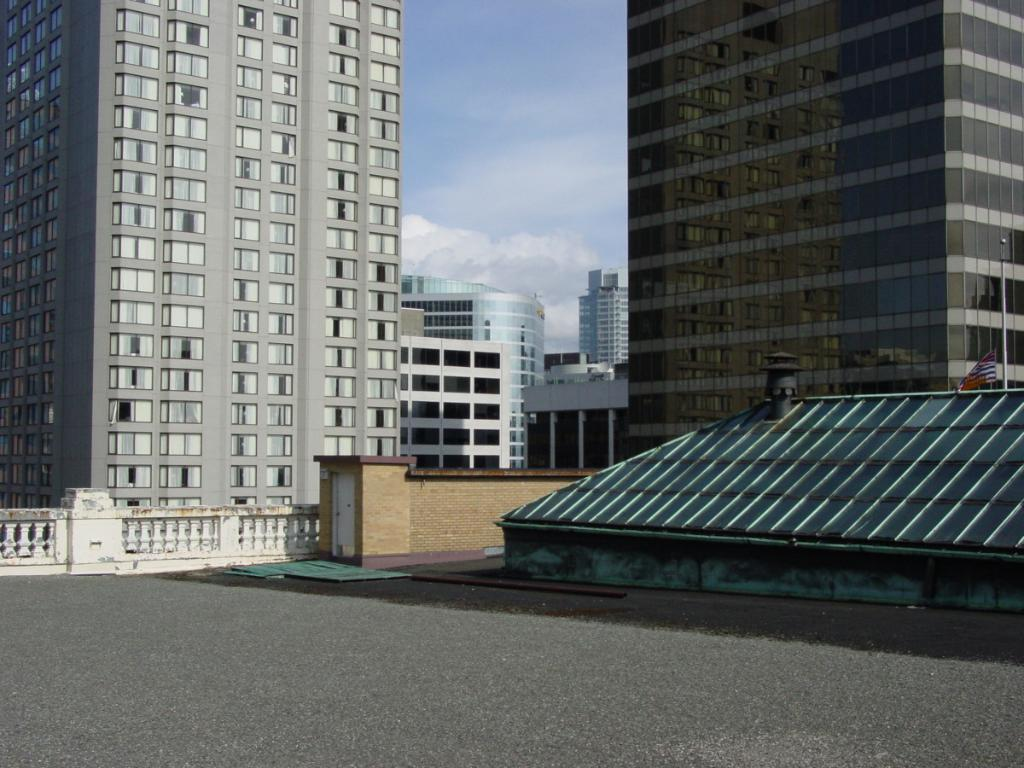What type of structures are present in the image? There are buildings in the image. What feature do the buildings have? The buildings have windows. What can be seen on the ground in the image? There is a road in the image. What is the condition of the sky in the image? The sky is cloudy in the image. What is present near the buildings? There is a pole in the image. What is attached to the pole? There is a flag on the pole. Can you tell me how many bananas are hanging from the flagpole in the image? There are no bananas present in the image; only a flag is attached to the pole. What type of business is being conducted in the buildings in the image? The provided facts do not mention any specific businesses being conducted in the buildings. 